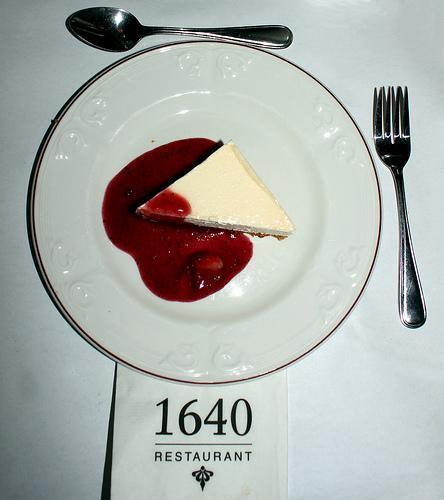How many forks are visible?
Give a very brief answer. 1. 